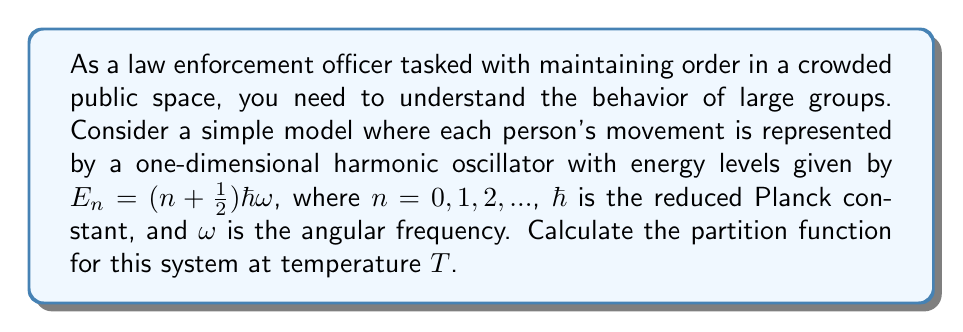Could you help me with this problem? Let's approach this step-by-step:

1) The partition function $Z$ is defined as:

   $$Z = \sum_{n=0}^{\infty} e^{-\beta E_n}$$

   where $\beta = \frac{1}{k_B T}$, $k_B$ is Boltzmann's constant, and $T$ is temperature.

2) Substitute the energy levels:

   $$Z = \sum_{n=0}^{\infty} e^{-\beta (n + \frac{1}{2})\hbar\omega}$$

3) Factor out the constant term:

   $$Z = e^{-\beta \frac{1}{2}\hbar\omega} \sum_{n=0}^{\infty} e^{-\beta n\hbar\omega}$$

4) Let $x = e^{-\beta\hbar\omega}$. Then:

   $$Z = e^{-\beta \frac{1}{2}\hbar\omega} \sum_{n=0}^{\infty} x^n$$

5) This is a geometric series with $|x| < 1$. The sum of this series is:

   $$\sum_{n=0}^{\infty} x^n = \frac{1}{1-x}$$

6) Substituting back:

   $$Z = e^{-\beta \frac{1}{2}\hbar\omega} \frac{1}{1-e^{-\beta\hbar\omega}}$$

7) This can be simplified to:

   $$Z = \frac{e^{-\beta \frac{1}{2}\hbar\omega}}{1-e^{-\beta\hbar\omega}}$$

This is the partition function for a simple harmonic oscillator.
Answer: $$Z = \frac{e^{-\beta \frac{1}{2}\hbar\omega}}{1-e^{-\beta\hbar\omega}}$$ 